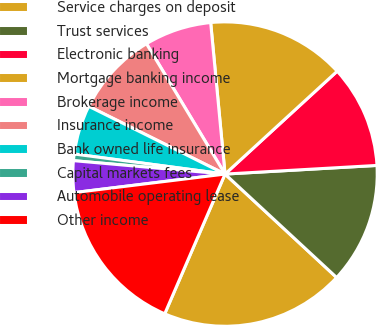Convert chart to OTSL. <chart><loc_0><loc_0><loc_500><loc_500><pie_chart><fcel>Service charges on deposit<fcel>Trust services<fcel>Electronic banking<fcel>Mortgage banking income<fcel>Brokerage income<fcel>Insurance income<fcel>Bank owned life insurance<fcel>Capital markets fees<fcel>Automobile operating lease<fcel>Other income<nl><fcel>19.59%<fcel>12.8%<fcel>10.91%<fcel>14.69%<fcel>7.13%<fcel>9.02%<fcel>5.24%<fcel>0.7%<fcel>3.35%<fcel>16.57%<nl></chart> 